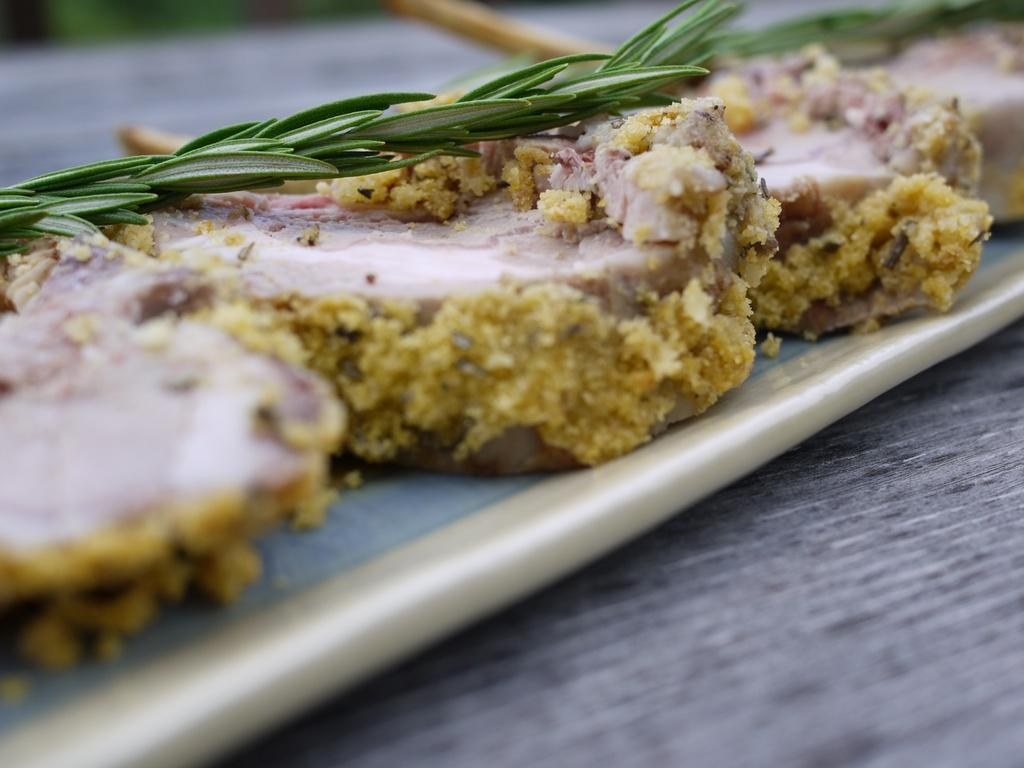What is present on the tray in the image? There is meat in the image, and it is placed on a tray. What herb can be seen in the image? There is a thyme leaf in the image. Where are the tray, meat, and thyme leaf located in the image? The tray, meat, and thyme leaf are placed on a table in the image. What type of prose is being recited by the baby in the image? There is no baby present in the image, and therefore no prose being recited. Where is the oven located in the image? There is no oven present in the image. 